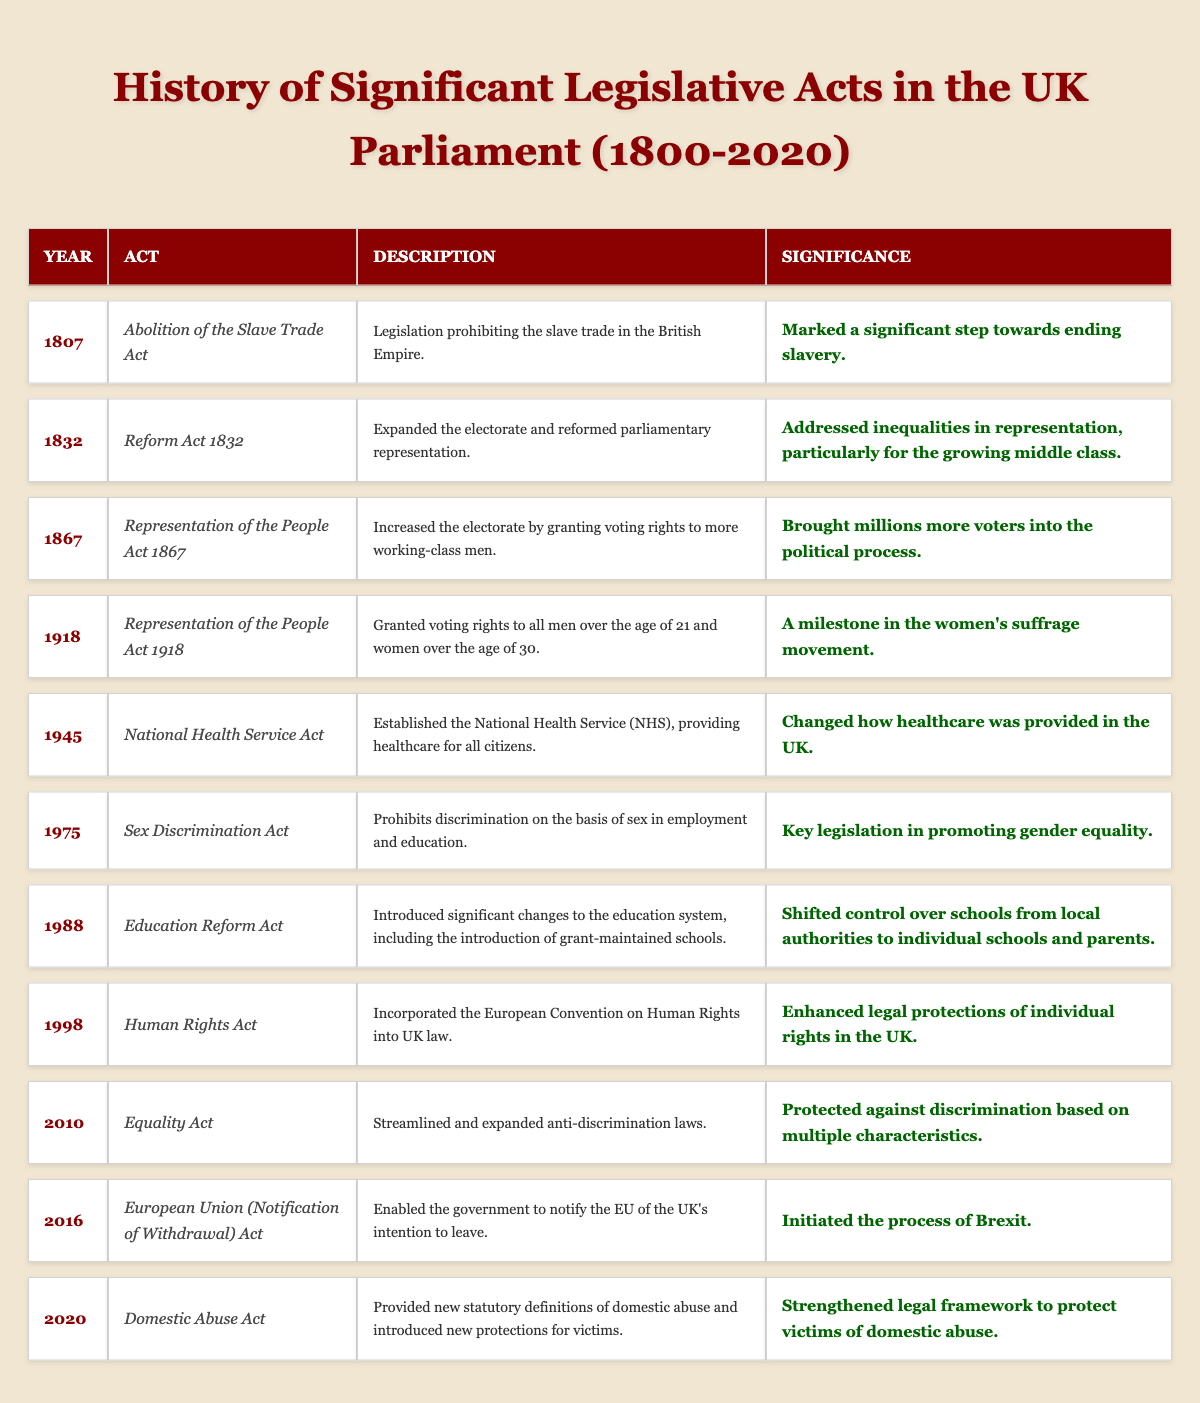What year was the Abolition of the Slave Trade Act passed? The table lists the act under the "Year" column, which shows 1807 for the Abolition of the Slave Trade Act.
Answer: 1807 Which act in 1918 granted voting rights to both men and women? The table states that the Representation of the People Act 1918 granted voting rights to all men over 21 and women over 30.
Answer: Representation of the People Act 1918 How many significant acts were passed before 1900? Looking at the table, there are 3 acts listed before the year 1900: the Abolition of the Slave Trade Act (1807), the Reform Act 1832, and the Representation of the People Act 1867.
Answer: 3 What is the significance of the 1945 National Health Service Act? The table indicates that the significance of the National Health Service Act is that it changed how healthcare was provided in the UK by establishing the NHS.
Answer: Changed healthcare provision in the UK Was the Sex Discrimination Act passed before or after 1980? The table indicates the date of the Sex Discrimination Act is 1975, which is before 1980.
Answer: Before Which act introduced changes to the education system in 1988 and what was its significance? According to the table, the Education Reform Act was passed in 1988, which introduced significant changes, including control over schools shifting to parents and individual schools.
Answer: Education Reform Act; shifted control over schools What is the difference in years between the Representation of the People Act 1918 and the Human Rights Act? The Representation of the People Act was passed in 1918 and the Human Rights Act in 1998. The difference is 1998 - 1918 = 80 years.
Answer: 80 years Name all acts that mention voting rights and their years. The table shows the Representation of the People Act 1867 (1867) and the Representation of the People Act 1918 (1918) as acts related to voting rights.
Answer: 1867, 1918 Which act is related to the concept of Brexit and what year was it enacted? The table states that the European Union (Notification of Withdrawal) Act, which initiated the process of Brexit, was enacted in 2016.
Answer: European Union (Notification of Withdrawal) Act; 2016 How many acts were focused on rights or discrimination from 1975 onward? From 1975, the table lists the Sex Discrimination Act (1975), Human Rights Act (1998), and Equality Act (2010). This totals to 3 acts focused on rights or discrimination.
Answer: 3 Is the Domestic Abuse Act the most recent significant legislative act listed in the table? The table places the Domestic Abuse Act in the year 2020, which is the last entry and thus confirms it is the most recent act.
Answer: Yes 